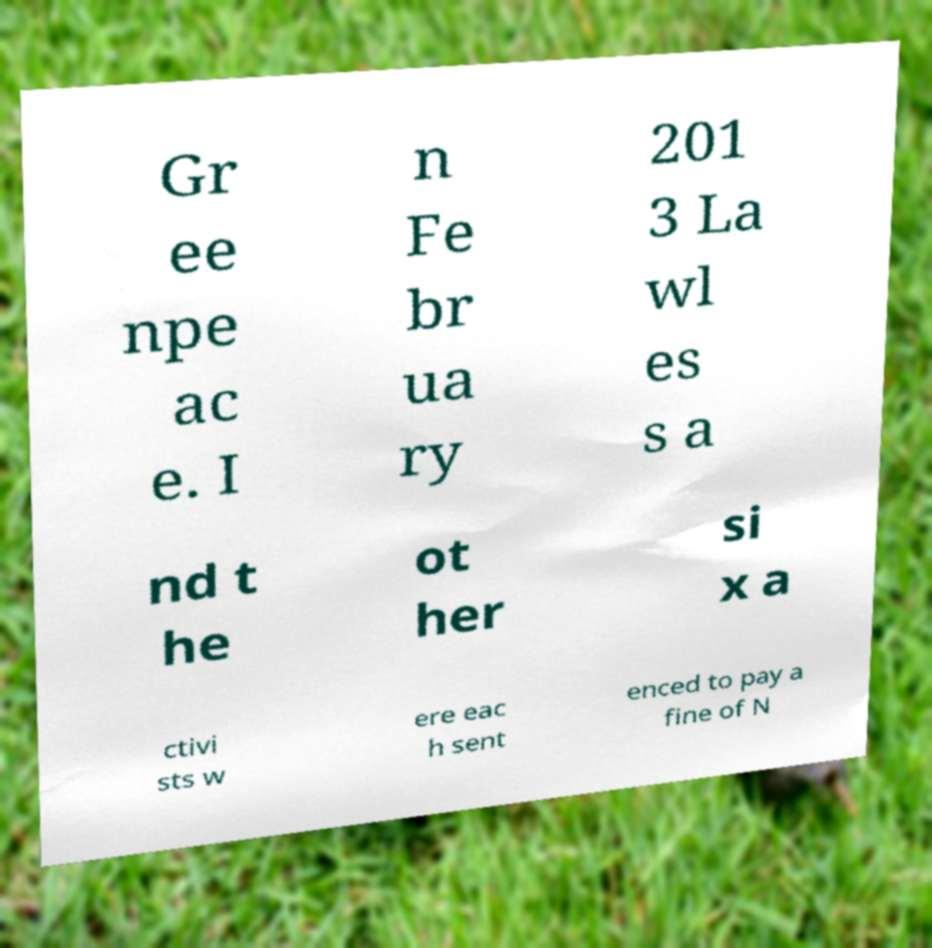For documentation purposes, I need the text within this image transcribed. Could you provide that? Gr ee npe ac e. I n Fe br ua ry 201 3 La wl es s a nd t he ot her si x a ctivi sts w ere eac h sent enced to pay a fine of N 